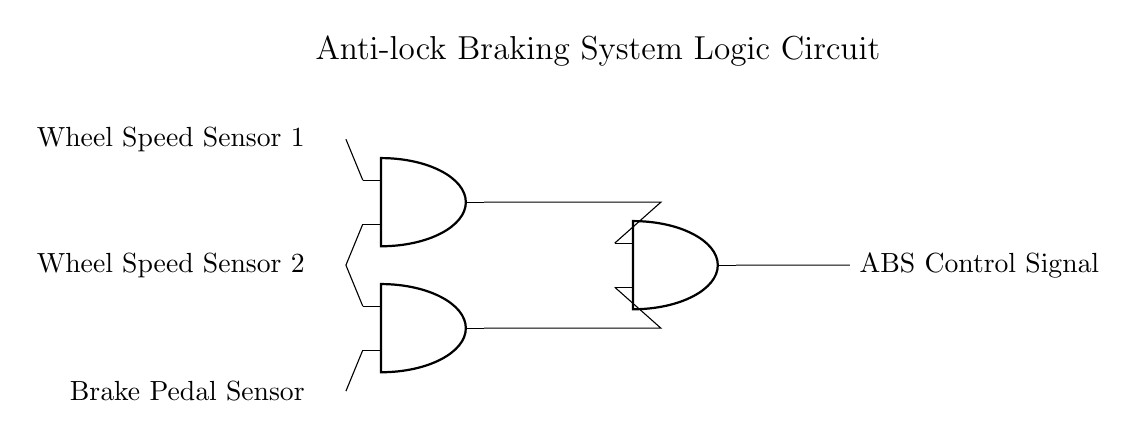What are the input signals? The input signals are the Wheel Speed Sensor 1, Wheel Speed Sensor 2, and Brake Pedal Sensor, which are clearly labeled in the circuit diagram.
Answer: Wheel Speed Sensor 1, Wheel Speed Sensor 2, Brake Pedal Sensor How many AND gates are in this circuit? The circuit diagram shows three AND gates, each represented clearly and labeled with their respective symbols as part of the logic circuit.
Answer: Three What does the output signal represent in the circuit? The output signal is labeled "ABS Control Signal," indicating its role in controlling the anti-lock braking system based on the inputs from the sensors.
Answer: ABS Control Signal Which sensors connect to the first AND gate? The first AND gate is connected to Wheel Speed Sensor 1 and Wheel Speed Sensor 2 as shown by the lines directing from these sensors to the inputs of the AND gate.
Answer: Wheel Speed Sensor 1 and Wheel Speed Sensor 2 What is the function of the second AND gate? The second AND gate combines the signals from the Brake Pedal Sensor and Wheel Speed Sensor 2, allowing it to determine if both conditions are met for braking, which is crucial for ABS functionality.
Answer: Combine signals for braking If Wheel Speed Sensor 1 is off, what will happen at the output? If Wheel Speed Sensor 1 is off, the output of the first AND gate will be off, which would prevent the ABS Control Signal from being active, indicating that the brakes may not be engaged properly.
Answer: Off Explain the role of the AND gates in this circuit. The AND gates function as decision-making components that only produce an output when certain conditions (inputs from the sensors) are met. The combination of inputs determines the ABS's operation, enhancing vehicle safety by controlling braking.
Answer: Conditional outputs 